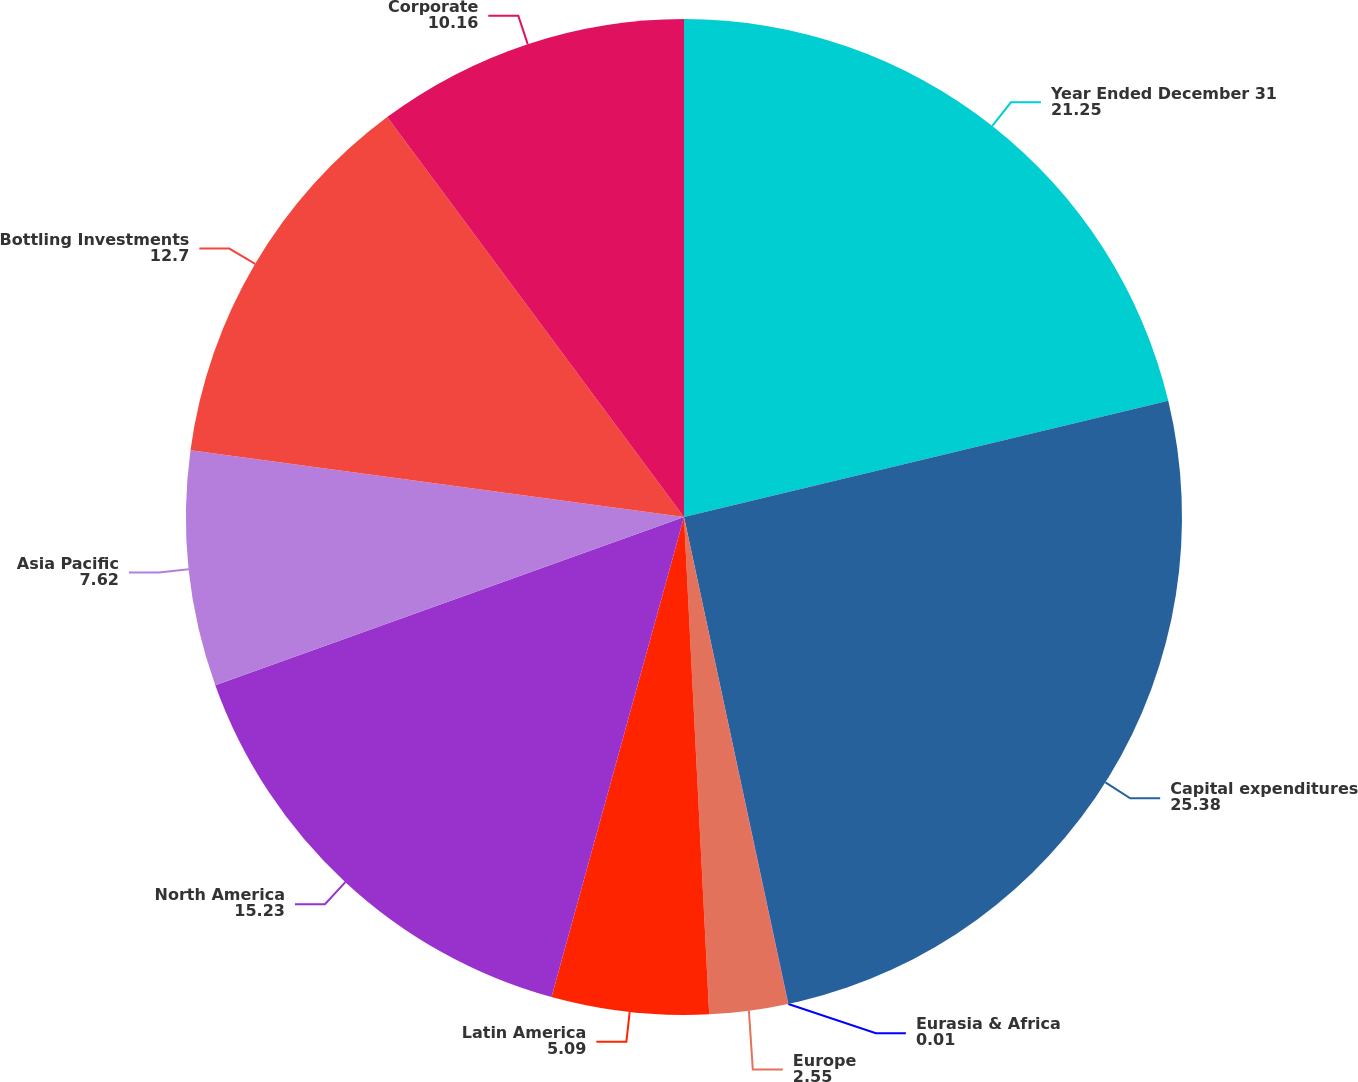<chart> <loc_0><loc_0><loc_500><loc_500><pie_chart><fcel>Year Ended December 31<fcel>Capital expenditures<fcel>Eurasia & Africa<fcel>Europe<fcel>Latin America<fcel>North America<fcel>Asia Pacific<fcel>Bottling Investments<fcel>Corporate<nl><fcel>21.25%<fcel>25.38%<fcel>0.01%<fcel>2.55%<fcel>5.09%<fcel>15.23%<fcel>7.62%<fcel>12.7%<fcel>10.16%<nl></chart> 